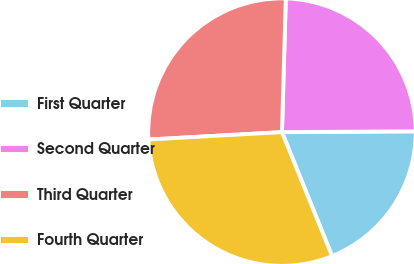<chart> <loc_0><loc_0><loc_500><loc_500><pie_chart><fcel>First Quarter<fcel>Second Quarter<fcel>Third Quarter<fcel>Fourth Quarter<nl><fcel>18.98%<fcel>24.45%<fcel>26.34%<fcel>30.23%<nl></chart> 